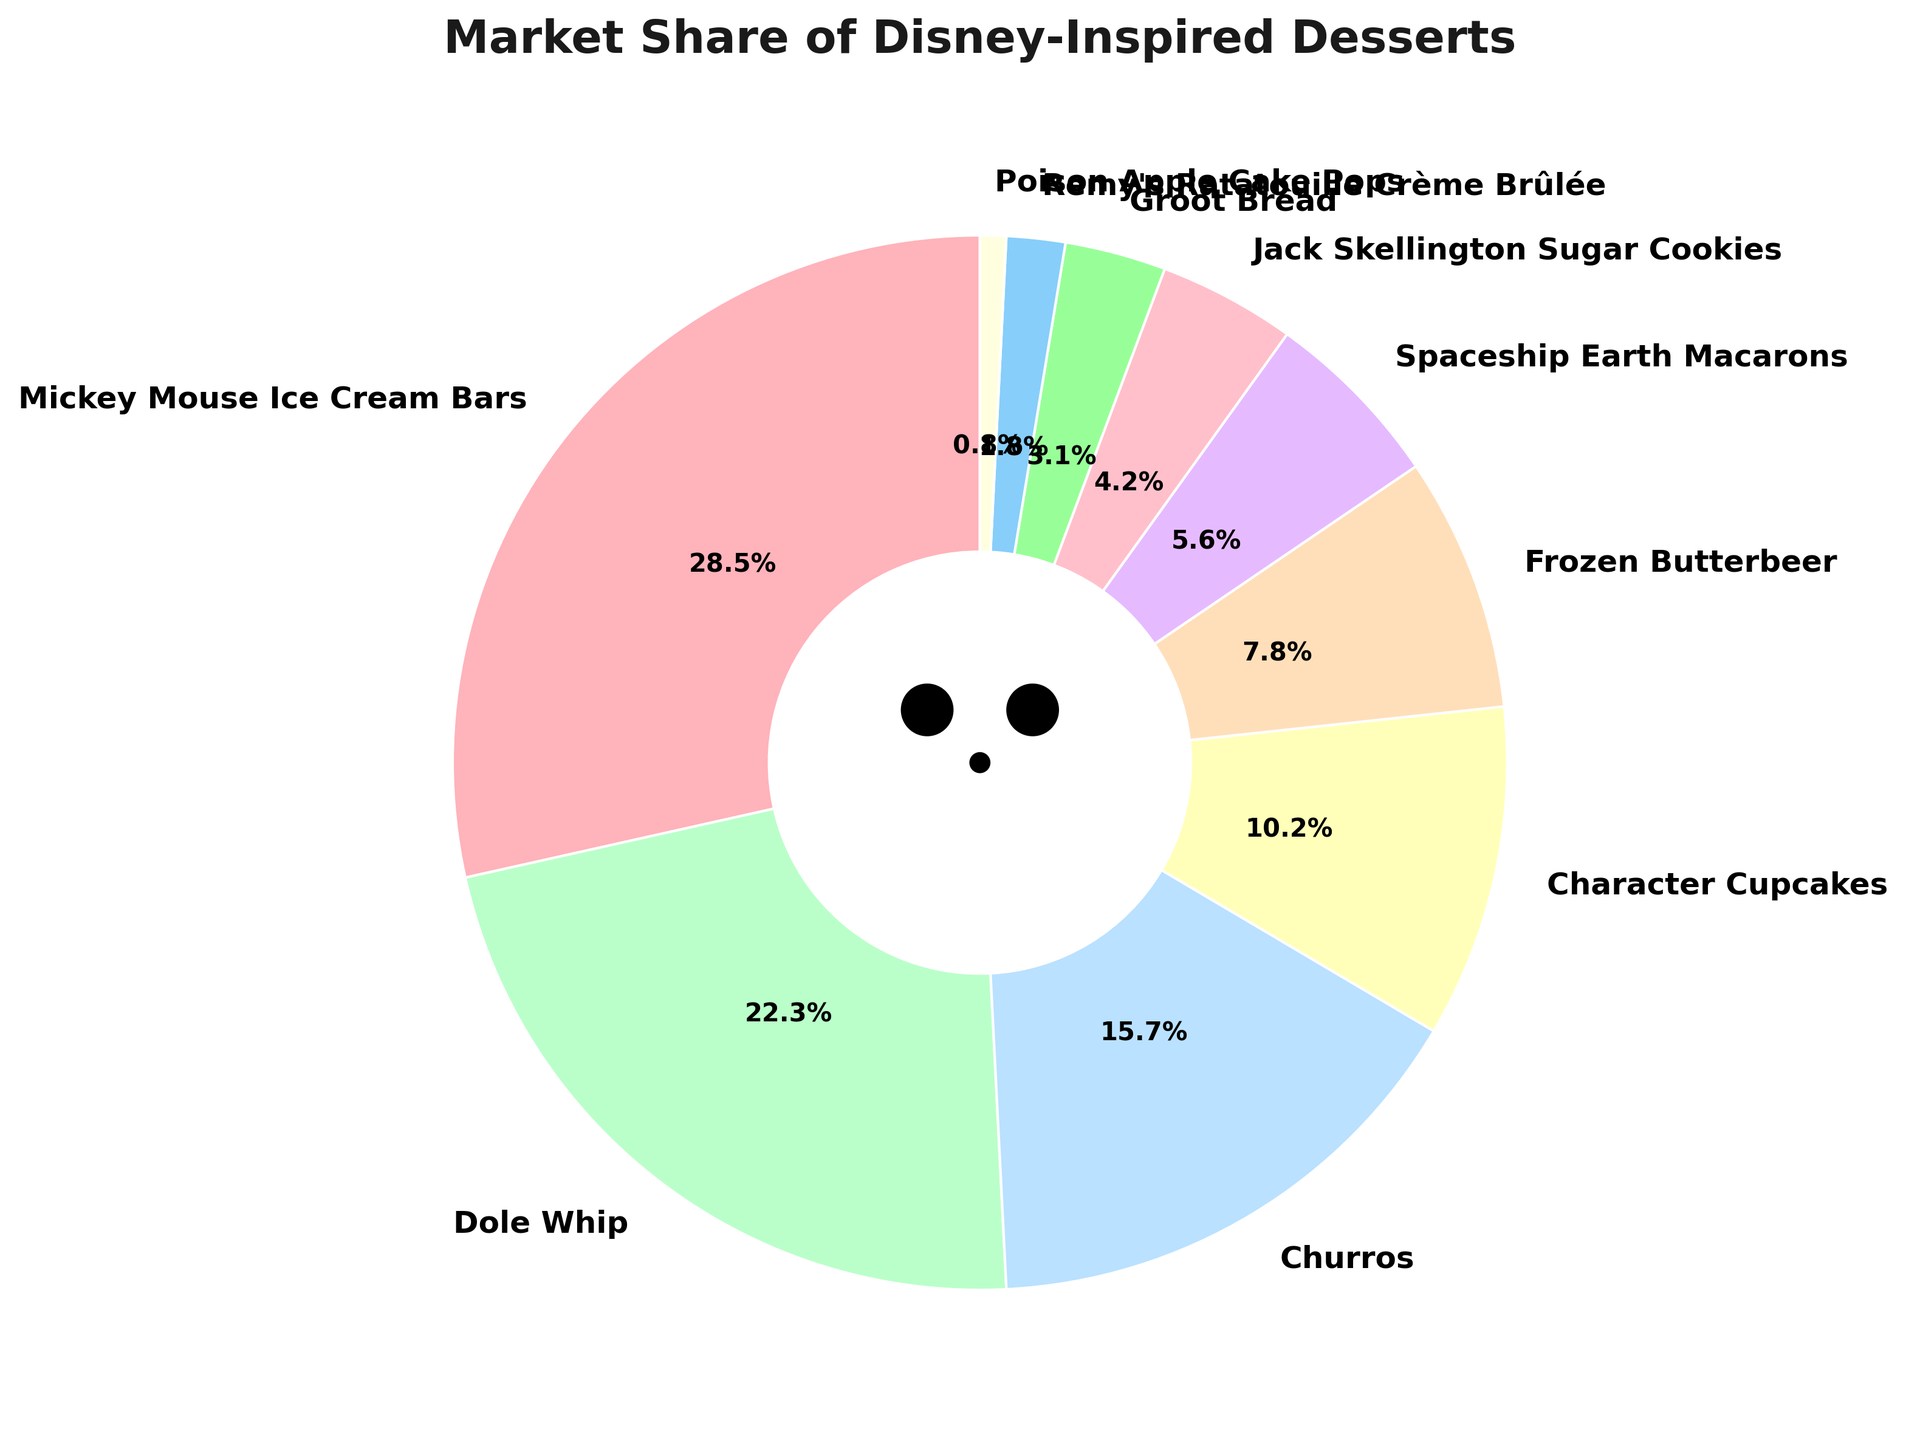Which dessert has the highest market share? The dessert with the highest market share is represented by the largest wedge in the pie chart. By inspecting the chart, the Mickey Mouse Ice Cream Bars have the largest wedge.
Answer: Mickey Mouse Ice Cream Bars What is the combined market share of Dole Whip and Spaceship Earth Macarons? To find the combined market share, add the individual market shares of Dole Whip (22.3%) and Spaceship Earth Macarons (5.6%). The calculation is 22.3 + 5.6 = 27.9%
Answer: 27.9% How much larger is the market share of Mickey Mouse Ice Cream Bars compared to Churros? Subtract the market share of Churros (15.7%) from that of Mickey Mouse Ice Cream Bars (28.5%). The difference is 28.5 - 15.7 = 12.8%
Answer: 12.8% Which dessert has the smallest market share and what is it? The smallest market share is represented by the smallest wedge in the pie chart. By inspecting the chart, Poison Apple Cake Pops have the smallest wedge with a market share of 0.8%.
Answer: Poison Apple Cake Pops, 0.8% Are Character Cupcakes more popular than Frozen Butterbeer? Compare the market share of Character Cupcakes (10.2%) with that of Frozen Butterbeer (7.8%). Character Cupcakes have a higher market share.
Answer: Yes What is the total market share of desserts with more than 20%? The only desserts with more than 20% are Mickey Mouse Ice Cream Bars (28.5%) and Dole Whip (22.3%). Add their market shares: 28.5 + 22.3 = 50.8%
Answer: 50.8% What is the market share of the least popular dessert named after a character? From the pie chart, the least popular character-named dessert is Jack Skellington Sugar Cookies with a market share of 4.2%.
Answer: 4.2% How do the combined market shares of desserts with less than 5% compare to the market share of Churros? First, add the market shares of desserts with less than 5%: Jack Skellington Sugar Cookies (4.2%), Groot Bread (3.1%), Remy's Ratatouille Crème Brûlée (1.8%), and Poison Apple Cake Pops (0.8%). The total is 4.2 + 3.1 + 1.8 + 0.8 = 9.9%. Compare this to the market share of Churros (15.7%).
Answer: Less than What percentage of the pie chart is taken up by desserts with a market share of less than 10%? Add the market shares of all desserts with less than 10%: Character Cupcakes (10.2%), Frozen Butterbeer (7.8%), Spaceship Earth Macarons (5.6%), Jack Skellington Sugar Cookies (4.2%), Groot Bread (3.1%), Remy's Ratatouille Crème Brûlée (1.8%), and Poison Apple Cake Pops (0.8%). The total is 10.2 + 7.8 + 5.6 + 4.2 + 3.1 + 1.8 + 0.8 = 33.5%
Answer: 33.5% 